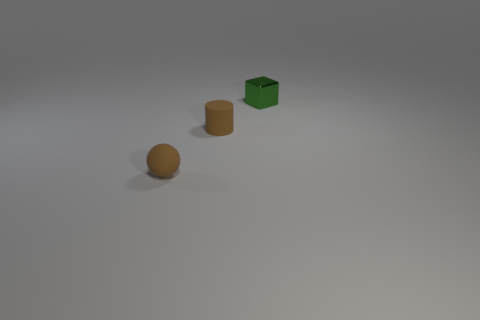Can you describe the lighting and shadow direction in the scene? The scene is softly lit from the upper right-hand side, as evidenced by the shadows that are cast towards the lower left side of each object, creating a gentle contrast between light and shadow across the objects and the surface. 